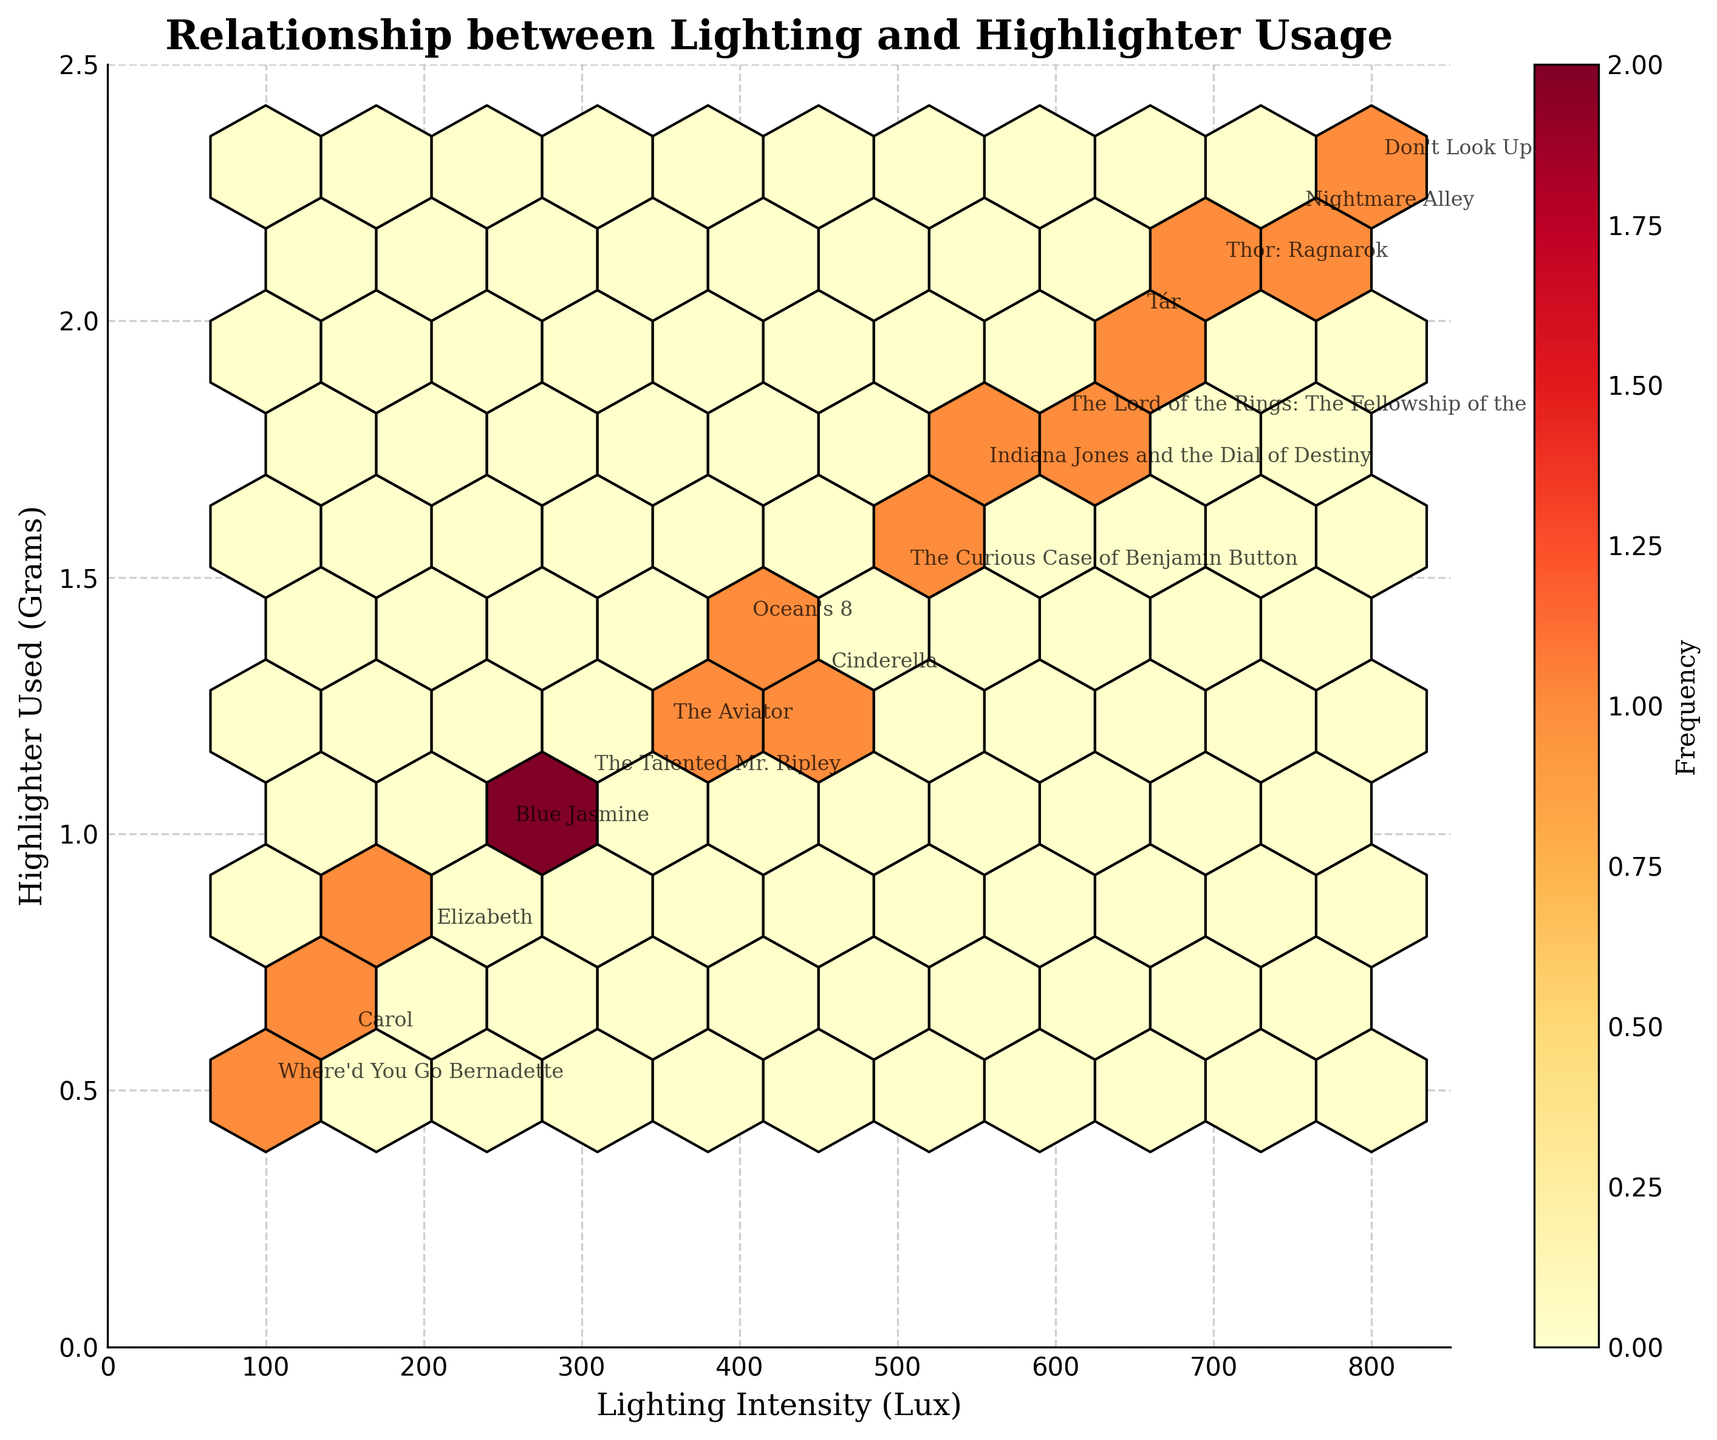What's the title of the plot? The title of the plot is usually displayed at the top of the figure prominently.
Answer: Relationship between Lighting and Highlighter Usage What are the labels of the axes? The x-axis label is typically found beneath the horizontal axis, and the y-axis label is next to the vertical axis. In this plot, they are clearly specified.
Answer: Lighting Intensity (Lux) and Highlighter Used (Grams) Which film set was used as a reference for the lowest lighting intensity in the plot? Locate the data point associated with the lowest value on the x-axis, then refer to the annotation provided for that point.
Answer: Where'd You Go Bernadette Which film set required the most highlighter under its lighting conditions? Find the highest value on the y-axis (Highlighter Used in Grams) and identify the film set annotation associated with it.
Answer: Don't Look Up How many film sets have lighting intensity above 500 Lux? Count the number of data points where the x-value (Lighting Intensity Lux) exceeds 500.
Answer: 7 What is the general trend observable between lighting intensity and the amount of highlighter used? Examine the pattern formed by the hexbin accumulation, the overall trend line that could be inferred from the concentration of points.
Answer: Increased lighting intensity generally correlates with more highlighter used Which film set is annotated at lighting intensity of 650 Lux and how much highlighter was used for it? Locate the point at 650 Lux on the x-axis and check the annotation for this point; note the corresponding y-value.
Answer: Tár, 2.0 grams Compare the highlighter used in "Cinderella" and "Ocean's 8" under their respective lighting conditions. Which one used more? Locate the annotations for "Cinderella" and "Ocean's 8" on the plot and compare their y-values (Highlighter Used in Grams).
Answer: Ocean's 8 used more How does the frequency vary across different sections of the hexbin plot? Examine the color gradient and density of the hexagonal bins, as the color intensity indicates frequency.
Answer: The frequency is higher in areas with mid to high lighting intensity and highlighter usage, indicated by darker hexagons For the film "Blue Jasmine," what are the lighting intensity and highlighter usage values? Locate the annotation for "Blue Jasmine" on the plot; the corresponding x and y coordinates of this point give the values.
Answer: 250 Lux, 1.0 grams 